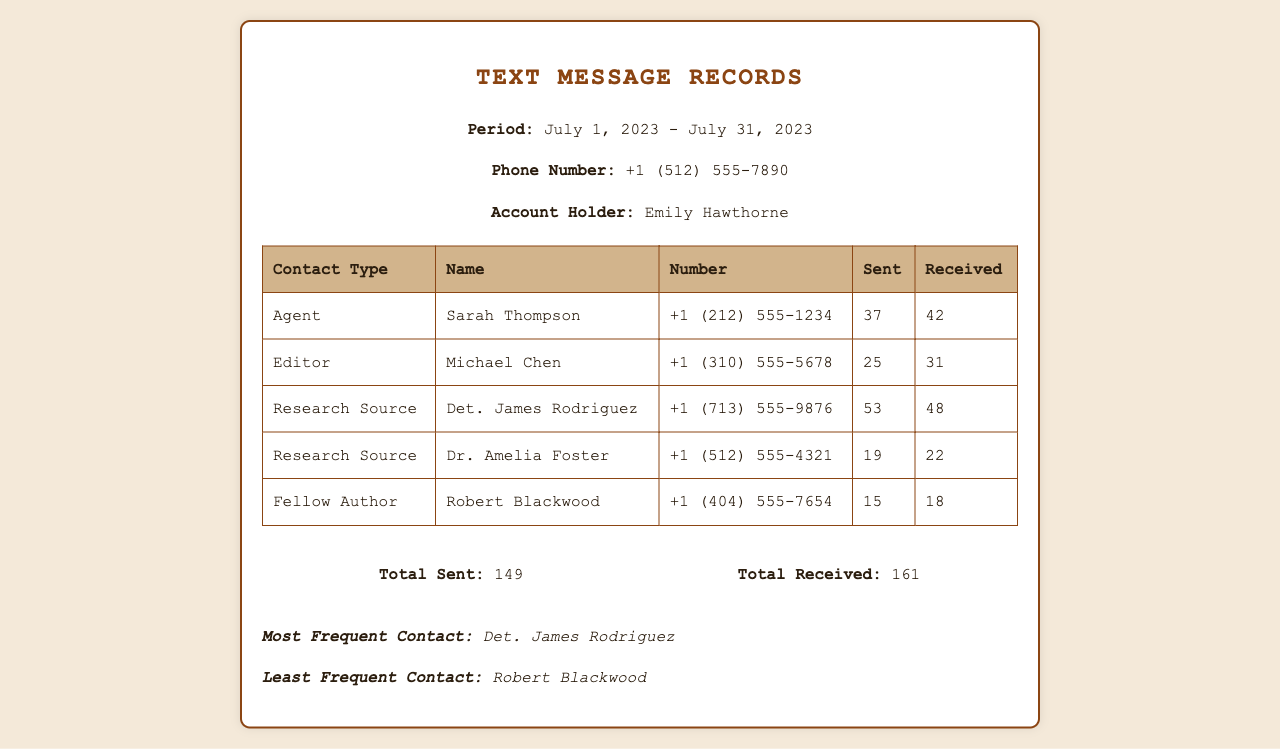what is the total number of text messages sent? The total number of text messages sent is calculated by summing all the messages sent in the document, which is 37 + 25 + 53 + 19 + 15 = 149.
Answer: 149 what is the phone number of Det. James Rodriguez? The document provides the contact details for Det. James Rodriguez, which includes his phone number listed as +1 (713) 555-9876.
Answer: +1 (713) 555-9876 who is the least frequent contact? The least frequent contact is identified in the document, which states Robert Blackwood as the person with the lowest interaction.
Answer: Robert Blackwood how many text messages did Michael Chen send? The document lists the number of messages sent to and from Michael Chen, indicating he sent a total of 25 messages.
Answer: 25 what is the total number of text messages received? The total number of text messages received is the sum of all received messages in the document, which is 42 + 31 + 48 + 22 + 18 = 161.
Answer: 161 which contact type has the highest number of received messages? The contact type with the highest number of received messages is revealed in the document, indicating Det. James Rodriguez received the most with 48 messages.
Answer: Research Source how many total messages were exchanged with Sarah Thompson? The document provides the sent and received message counts for Sarah Thompson, totaling 37 sent and 42 received, which sums to 79 messages exchanged.
Answer: 79 what is the account holder's name? The document states the account holder's name at the top, which is clearly indicated as Emily Hawthorne.
Answer: Emily Hawthorne who sent the most messages? The document discloses that Det. James Rodriguez sent a total of 53 messages, marking him as the person who sent the most.
Answer: Det. James Rodriguez 